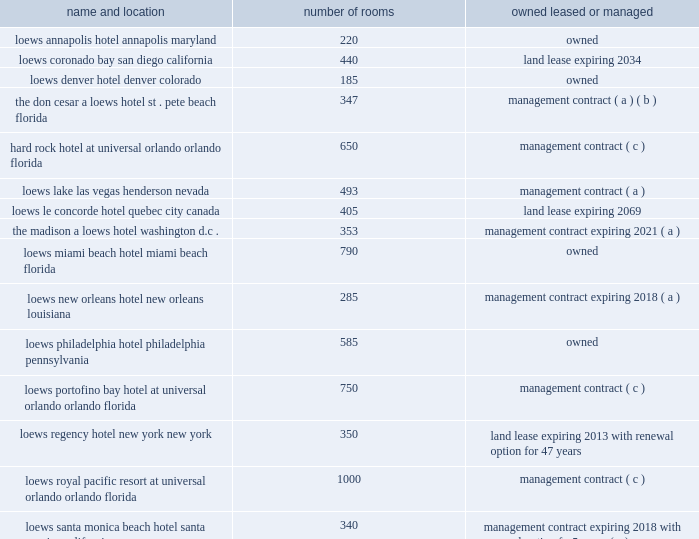Item 1 .
Business loews hotels holding corporation the subsidiaries of loews hotels holding corporation ( 201cloews hotels 201d ) , our wholly owned subsidiary , presently operate the following 18 hotels .
Loews hotels accounted for 2.0% ( 2.0 % ) , 2.9% ( 2.9 % ) and 2.7% ( 2.7 % ) of our consolidated total revenue for the years ended december 31 , 2009 , 2008 and 2007 .
Number of name and location rooms owned , leased or managed loews annapolis hotel 220 owned annapolis , maryland loews coronado bay 440 land lease expiring 2034 san diego , california loews denver hotel 185 owned denver , colorado the don cesar , a loews hotel 347 management contract ( a ) ( b ) st .
Pete beach , florida hard rock hotel , 650 management contract ( c ) at universal orlando orlando , florida loews lake las vegas 493 management contract ( a ) henderson , nevada loews le concorde hotel 405 land lease expiring 2069 quebec city , canada the madison , a loews hotel 353 management contract expiring 2021 ( a ) washington , d.c .
Loews miami beach hotel 790 owned miami beach , florida loews new orleans hotel 285 management contract expiring 2018 ( a ) new orleans , louisiana loews philadelphia hotel 585 owned philadelphia , pennsylvania loews portofino bay hotel , 750 management contract ( c ) at universal orlando orlando , florida loews regency hotel 350 land lease expiring 2013 , with renewal option new york , new york for 47 years loews royal pacific resort 1000 management contract ( c ) at universal orlando orlando , florida loews santa monica beach hotel 340 management contract expiring 2018 , with santa monica , california renewal option for 5 years ( a ) loews vanderbilt hotel 340 owned nashville , tennessee loews ventana canyon 400 management contract expiring 2019 ( a ) tucson , arizona loews hotel vogue 140 owned montreal , canada ( a ) these management contracts are subject to termination rights .
( b ) a loews hotels subsidiary is a 20% ( 20 % ) owner of the hotel , which is being operated by loews hotels pursuant to a management contract .
( c ) a loews hotels subsidiary is a 50% ( 50 % ) owner of these hotels located at the universal orlando theme park , through a joint venture with universal studios and the rank group .
The hotels are on land leased by the joint venture and are operated by loews hotels pursuant to a management contract. .
Item 1 .
Business loews hotels holding corporation the subsidiaries of loews hotels holding corporation ( 201cloews hotels 201d ) , our wholly owned subsidiary , presently operate the following 18 hotels .
Loews hotels accounted for 2.0% ( 2.0 % ) , 2.9% ( 2.9 % ) and 2.7% ( 2.7 % ) of our consolidated total revenue for the years ended december 31 , 2009 , 2008 and 2007 .
Number of name and location rooms owned , leased or managed loews annapolis hotel 220 owned annapolis , maryland loews coronado bay 440 land lease expiring 2034 san diego , california loews denver hotel 185 owned denver , colorado the don cesar , a loews hotel 347 management contract ( a ) ( b ) st .
Pete beach , florida hard rock hotel , 650 management contract ( c ) at universal orlando orlando , florida loews lake las vegas 493 management contract ( a ) henderson , nevada loews le concorde hotel 405 land lease expiring 2069 quebec city , canada the madison , a loews hotel 353 management contract expiring 2021 ( a ) washington , d.c .
Loews miami beach hotel 790 owned miami beach , florida loews new orleans hotel 285 management contract expiring 2018 ( a ) new orleans , louisiana loews philadelphia hotel 585 owned philadelphia , pennsylvania loews portofino bay hotel , 750 management contract ( c ) at universal orlando orlando , florida loews regency hotel 350 land lease expiring 2013 , with renewal option new york , new york for 47 years loews royal pacific resort 1000 management contract ( c ) at universal orlando orlando , florida loews santa monica beach hotel 340 management contract expiring 2018 , with santa monica , california renewal option for 5 years ( a ) loews vanderbilt hotel 340 owned nashville , tennessee loews ventana canyon 400 management contract expiring 2019 ( a ) tucson , arizona loews hotel vogue 140 owned montreal , canada ( a ) these management contracts are subject to termination rights .
( b ) a loews hotels subsidiary is a 20% ( 20 % ) owner of the hotel , which is being operated by loews hotels pursuant to a management contract .
( c ) a loews hotels subsidiary is a 50% ( 50 % ) owner of these hotels located at the universal orlando theme park , through a joint venture with universal studios and the rank group .
The hotels are on land leased by the joint venture and are operated by loews hotels pursuant to a management contract. .
For the loews santa monica beach hotel , what is the final year of the management contract including renewals? 
Computations: (2018 + 5)
Answer: 2023.0. Item 1 .
Business loews hotels holding corporation the subsidiaries of loews hotels holding corporation ( 201cloews hotels 201d ) , our wholly owned subsidiary , presently operate the following 18 hotels .
Loews hotels accounted for 2.0% ( 2.0 % ) , 2.9% ( 2.9 % ) and 2.7% ( 2.7 % ) of our consolidated total revenue for the years ended december 31 , 2009 , 2008 and 2007 .
Number of name and location rooms owned , leased or managed loews annapolis hotel 220 owned annapolis , maryland loews coronado bay 440 land lease expiring 2034 san diego , california loews denver hotel 185 owned denver , colorado the don cesar , a loews hotel 347 management contract ( a ) ( b ) st .
Pete beach , florida hard rock hotel , 650 management contract ( c ) at universal orlando orlando , florida loews lake las vegas 493 management contract ( a ) henderson , nevada loews le concorde hotel 405 land lease expiring 2069 quebec city , canada the madison , a loews hotel 353 management contract expiring 2021 ( a ) washington , d.c .
Loews miami beach hotel 790 owned miami beach , florida loews new orleans hotel 285 management contract expiring 2018 ( a ) new orleans , louisiana loews philadelphia hotel 585 owned philadelphia , pennsylvania loews portofino bay hotel , 750 management contract ( c ) at universal orlando orlando , florida loews regency hotel 350 land lease expiring 2013 , with renewal option new york , new york for 47 years loews royal pacific resort 1000 management contract ( c ) at universal orlando orlando , florida loews santa monica beach hotel 340 management contract expiring 2018 , with santa monica , california renewal option for 5 years ( a ) loews vanderbilt hotel 340 owned nashville , tennessee loews ventana canyon 400 management contract expiring 2019 ( a ) tucson , arizona loews hotel vogue 140 owned montreal , canada ( a ) these management contracts are subject to termination rights .
( b ) a loews hotels subsidiary is a 20% ( 20 % ) owner of the hotel , which is being operated by loews hotels pursuant to a management contract .
( c ) a loews hotels subsidiary is a 50% ( 50 % ) owner of these hotels located at the universal orlando theme park , through a joint venture with universal studios and the rank group .
The hotels are on land leased by the joint venture and are operated by loews hotels pursuant to a management contract. .
Item 1 .
Business loews hotels holding corporation the subsidiaries of loews hotels holding corporation ( 201cloews hotels 201d ) , our wholly owned subsidiary , presently operate the following 18 hotels .
Loews hotels accounted for 2.0% ( 2.0 % ) , 2.9% ( 2.9 % ) and 2.7% ( 2.7 % ) of our consolidated total revenue for the years ended december 31 , 2009 , 2008 and 2007 .
Number of name and location rooms owned , leased or managed loews annapolis hotel 220 owned annapolis , maryland loews coronado bay 440 land lease expiring 2034 san diego , california loews denver hotel 185 owned denver , colorado the don cesar , a loews hotel 347 management contract ( a ) ( b ) st .
Pete beach , florida hard rock hotel , 650 management contract ( c ) at universal orlando orlando , florida loews lake las vegas 493 management contract ( a ) henderson , nevada loews le concorde hotel 405 land lease expiring 2069 quebec city , canada the madison , a loews hotel 353 management contract expiring 2021 ( a ) washington , d.c .
Loews miami beach hotel 790 owned miami beach , florida loews new orleans hotel 285 management contract expiring 2018 ( a ) new orleans , louisiana loews philadelphia hotel 585 owned philadelphia , pennsylvania loews portofino bay hotel , 750 management contract ( c ) at universal orlando orlando , florida loews regency hotel 350 land lease expiring 2013 , with renewal option new york , new york for 47 years loews royal pacific resort 1000 management contract ( c ) at universal orlando orlando , florida loews santa monica beach hotel 340 management contract expiring 2018 , with santa monica , california renewal option for 5 years ( a ) loews vanderbilt hotel 340 owned nashville , tennessee loews ventana canyon 400 management contract expiring 2019 ( a ) tucson , arizona loews hotel vogue 140 owned montreal , canada ( a ) these management contracts are subject to termination rights .
( b ) a loews hotels subsidiary is a 20% ( 20 % ) owner of the hotel , which is being operated by loews hotels pursuant to a management contract .
( c ) a loews hotels subsidiary is a 50% ( 50 % ) owner of these hotels located at the universal orlando theme park , through a joint venture with universal studios and the rank group .
The hotels are on land leased by the joint venture and are operated by loews hotels pursuant to a management contract. .
How many rooms does loews hotel have outside the us? 
Computations: (140 + 405)
Answer: 545.0. 